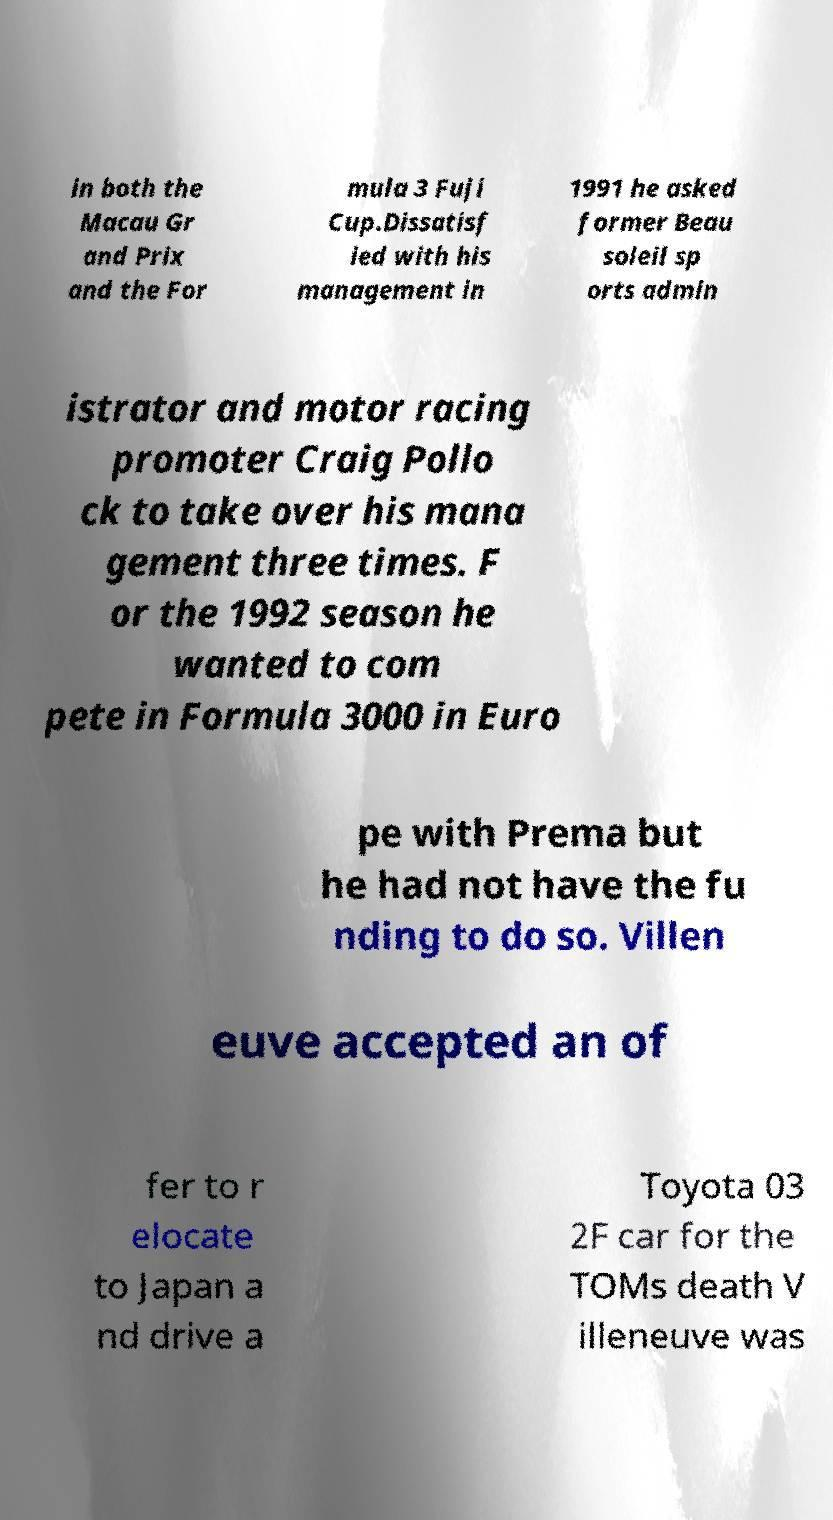Can you read and provide the text displayed in the image?This photo seems to have some interesting text. Can you extract and type it out for me? in both the Macau Gr and Prix and the For mula 3 Fuji Cup.Dissatisf ied with his management in 1991 he asked former Beau soleil sp orts admin istrator and motor racing promoter Craig Pollo ck to take over his mana gement three times. F or the 1992 season he wanted to com pete in Formula 3000 in Euro pe with Prema but he had not have the fu nding to do so. Villen euve accepted an of fer to r elocate to Japan a nd drive a Toyota 03 2F car for the TOMs death V illeneuve was 